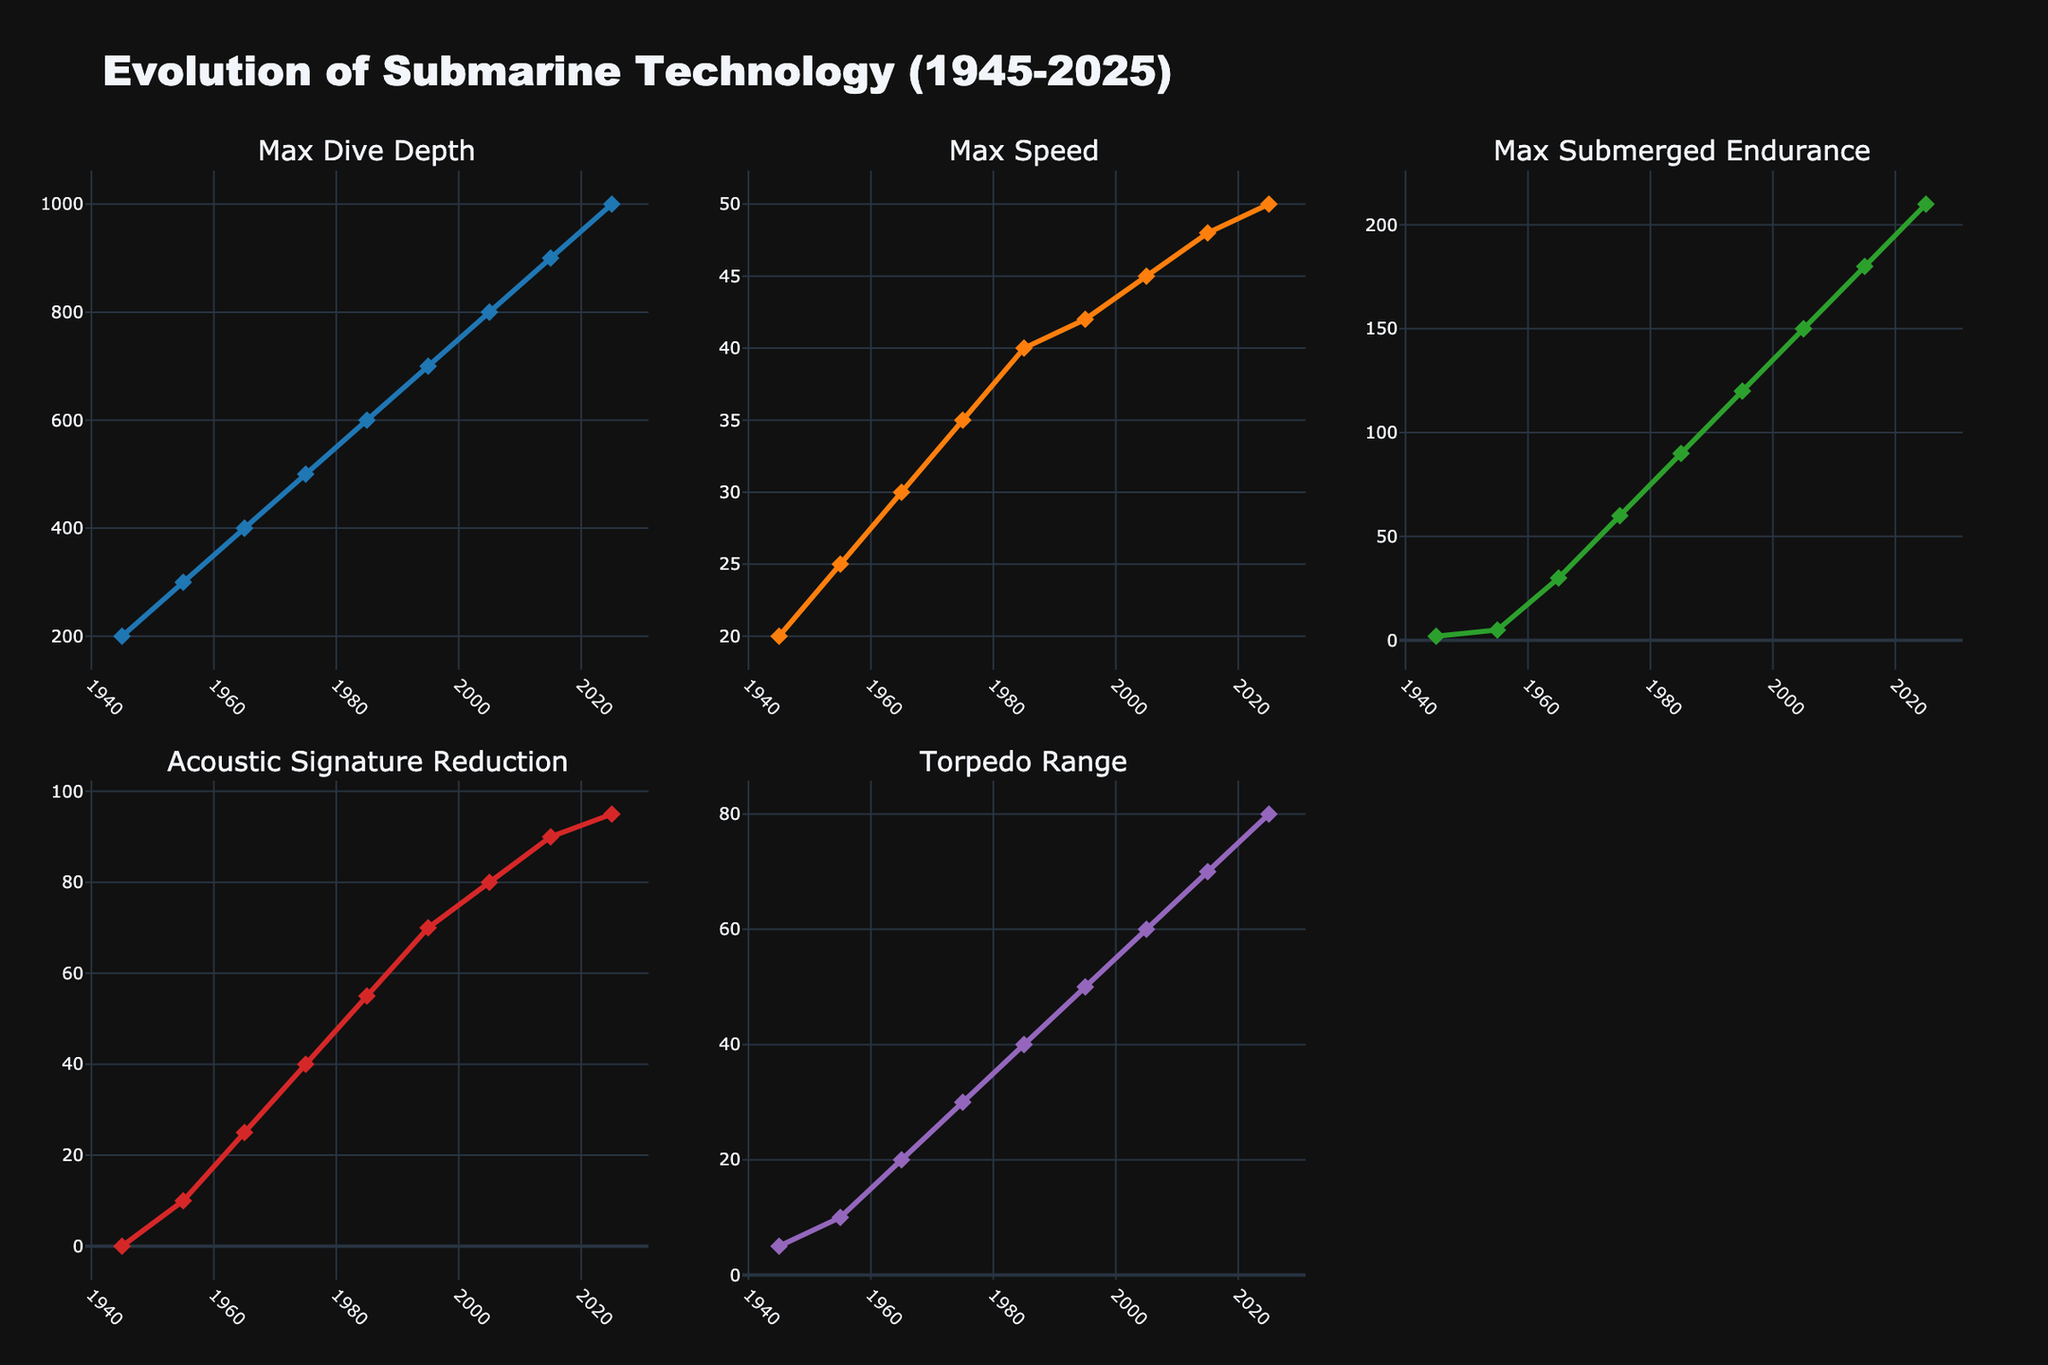What is the increase in Max Submerged Endurance from 1985 to 2015? To find the increase in Max Submerged Endurance between 1985 and 2015, subtract the 1985 value from the 2015 value. The value in 1985 is 90 days, and in 2015 it is 180 days. Therefore, the increase is 180 - 90 = 90 days.
Answer: 90 days Which year had the greatest improvement in Acoustic Signature Reduction compared to the previous decade? Compare the Acoustic Signature Reduction values for each decade and find the year with the largest increase. From the data: 1955-1945 (10%), 1965-1955 (15%), 1975-1965 (15%), 1985-1975 (15%), 1995-1985 (15%), 2005-1995 (10%), 2015-2005 (10%), 2025-2015 (5%). The largest single-decade improvement is between 1965 and 1975 with an increase of 15%.
Answer: 1965 to 1975 How does the Max Speed in 2025 compare to the Max Speed in 1945? Compare the Max Speed values for 2025 and 1945 directly from the figure. In 1945, the Max Speed is 20 knots, and in 2025 it is 50 knots. Thus, the 2025 value is 30 knots higher than in 1945.
Answer: 30 knots higher Was there a decade where Max Dive Depth did not increase? Check each decade's Max Dive Depth values to see if there's any decade where there is no increase. By analyzing the data, each decade has an increase in Max Dive Depth.
Answer: No What is the difference in Torpedo Range between the beginning and end of the study period (1945 to 2025)? Subtract the Torpedo Range value in 1945 from the Torpedo Range value in 2025. The values are 5 km in 1945 and 80 km in 2025. Therefore, the difference is 80 - 5 = 75 km.
Answer: 75 km Which metric has shown the most consistent growth over the years? Assess the linearity and regularity of the growth of each metric from the plot. Max Submerged Endurance shows regular and consistent growth from decade to decade without sudden spikes or plateaus.
Answer: Max Submerged Endurance Compare the Acoustic Signature Reduction percentages in 1975 and 2025. The Acoustic Signature Reduction in 1975 is 40%, and in 2025 it is 95%. The difference between these values is 95% - 40% = 55%.
Answer: 55% difference Which year had the lowest Max Dive Depth and what was it? From the data and the figure, the year 1945 had the lowest Max Dive Depth, which was 200 meters.
Answer: 1945, 200 meters What is the average Max Speed across all the years provided? Sum up the Max Speed values for all provided years and divide by the number of years. (20 + 25 + 30 + 35 + 40 + 42 + 45 + 48 + 50) / 9 = 335 / 9 ≈ 37.22 knots.
Answer: 37.22 knots 